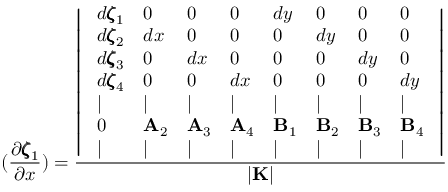Convert formula to latex. <formula><loc_0><loc_0><loc_500><loc_500>( \frac { \partial \pm b { \zeta } _ { 1 } } { \partial x } ) = \frac { \left | \begin{array} { l l l l l l l l } { d \pm b { \zeta } _ { 1 } } & { 0 } & { 0 } & { 0 } & { d y } & { 0 } & { 0 } & { 0 } \\ { d \pm b { \zeta } _ { 2 } } & { d x } & { 0 } & { 0 } & { 0 } & { d y } & { 0 } & { 0 } \\ { d \pm b { \zeta } _ { 3 } } & { 0 } & { d x } & { 0 } & { 0 } & { 0 } & { d y } & { 0 } \\ { d \pm b { \zeta } _ { 4 } } & { 0 } & { 0 } & { d x } & { 0 } & { 0 } & { 0 } & { d y } \\ { | } & { | } & { | } & { | } & { | } & { | } & { | } & { | } \\ { 0 } & { { A } _ { 2 } } & { { A } _ { 3 } } & { { A } _ { 4 } } & { { B } _ { 1 } } & { { B } _ { 2 } } & { { B } _ { 3 } } & { { B } _ { 4 } } \\ { | } & { | } & { | } & { | } & { | } & { | } & { | } & { | } \end{array} \right | } { | { K } | }</formula> 